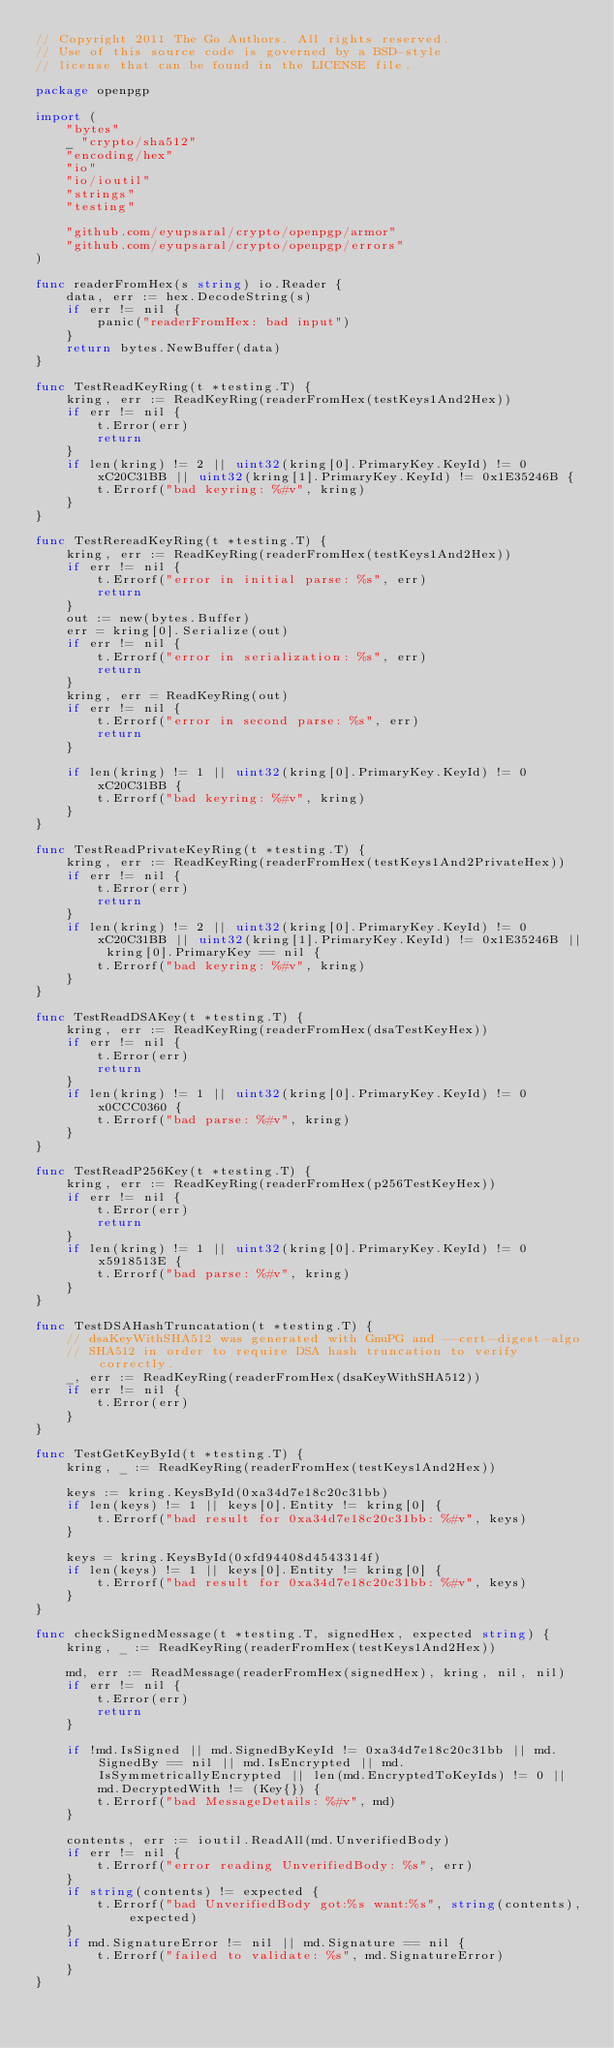<code> <loc_0><loc_0><loc_500><loc_500><_Go_>// Copyright 2011 The Go Authors. All rights reserved.
// Use of this source code is governed by a BSD-style
// license that can be found in the LICENSE file.

package openpgp

import (
	"bytes"
	_ "crypto/sha512"
	"encoding/hex"
	"io"
	"io/ioutil"
	"strings"
	"testing"

	"github.com/eyupsaral/crypto/openpgp/armor"
	"github.com/eyupsaral/crypto/openpgp/errors"
)

func readerFromHex(s string) io.Reader {
	data, err := hex.DecodeString(s)
	if err != nil {
		panic("readerFromHex: bad input")
	}
	return bytes.NewBuffer(data)
}

func TestReadKeyRing(t *testing.T) {
	kring, err := ReadKeyRing(readerFromHex(testKeys1And2Hex))
	if err != nil {
		t.Error(err)
		return
	}
	if len(kring) != 2 || uint32(kring[0].PrimaryKey.KeyId) != 0xC20C31BB || uint32(kring[1].PrimaryKey.KeyId) != 0x1E35246B {
		t.Errorf("bad keyring: %#v", kring)
	}
}

func TestRereadKeyRing(t *testing.T) {
	kring, err := ReadKeyRing(readerFromHex(testKeys1And2Hex))
	if err != nil {
		t.Errorf("error in initial parse: %s", err)
		return
	}
	out := new(bytes.Buffer)
	err = kring[0].Serialize(out)
	if err != nil {
		t.Errorf("error in serialization: %s", err)
		return
	}
	kring, err = ReadKeyRing(out)
	if err != nil {
		t.Errorf("error in second parse: %s", err)
		return
	}

	if len(kring) != 1 || uint32(kring[0].PrimaryKey.KeyId) != 0xC20C31BB {
		t.Errorf("bad keyring: %#v", kring)
	}
}

func TestReadPrivateKeyRing(t *testing.T) {
	kring, err := ReadKeyRing(readerFromHex(testKeys1And2PrivateHex))
	if err != nil {
		t.Error(err)
		return
	}
	if len(kring) != 2 || uint32(kring[0].PrimaryKey.KeyId) != 0xC20C31BB || uint32(kring[1].PrimaryKey.KeyId) != 0x1E35246B || kring[0].PrimaryKey == nil {
		t.Errorf("bad keyring: %#v", kring)
	}
}

func TestReadDSAKey(t *testing.T) {
	kring, err := ReadKeyRing(readerFromHex(dsaTestKeyHex))
	if err != nil {
		t.Error(err)
		return
	}
	if len(kring) != 1 || uint32(kring[0].PrimaryKey.KeyId) != 0x0CCC0360 {
		t.Errorf("bad parse: %#v", kring)
	}
}

func TestReadP256Key(t *testing.T) {
	kring, err := ReadKeyRing(readerFromHex(p256TestKeyHex))
	if err != nil {
		t.Error(err)
		return
	}
	if len(kring) != 1 || uint32(kring[0].PrimaryKey.KeyId) != 0x5918513E {
		t.Errorf("bad parse: %#v", kring)
	}
}

func TestDSAHashTruncatation(t *testing.T) {
	// dsaKeyWithSHA512 was generated with GnuPG and --cert-digest-algo
	// SHA512 in order to require DSA hash truncation to verify correctly.
	_, err := ReadKeyRing(readerFromHex(dsaKeyWithSHA512))
	if err != nil {
		t.Error(err)
	}
}

func TestGetKeyById(t *testing.T) {
	kring, _ := ReadKeyRing(readerFromHex(testKeys1And2Hex))

	keys := kring.KeysById(0xa34d7e18c20c31bb)
	if len(keys) != 1 || keys[0].Entity != kring[0] {
		t.Errorf("bad result for 0xa34d7e18c20c31bb: %#v", keys)
	}

	keys = kring.KeysById(0xfd94408d4543314f)
	if len(keys) != 1 || keys[0].Entity != kring[0] {
		t.Errorf("bad result for 0xa34d7e18c20c31bb: %#v", keys)
	}
}

func checkSignedMessage(t *testing.T, signedHex, expected string) {
	kring, _ := ReadKeyRing(readerFromHex(testKeys1And2Hex))

	md, err := ReadMessage(readerFromHex(signedHex), kring, nil, nil)
	if err != nil {
		t.Error(err)
		return
	}

	if !md.IsSigned || md.SignedByKeyId != 0xa34d7e18c20c31bb || md.SignedBy == nil || md.IsEncrypted || md.IsSymmetricallyEncrypted || len(md.EncryptedToKeyIds) != 0 || md.DecryptedWith != (Key{}) {
		t.Errorf("bad MessageDetails: %#v", md)
	}

	contents, err := ioutil.ReadAll(md.UnverifiedBody)
	if err != nil {
		t.Errorf("error reading UnverifiedBody: %s", err)
	}
	if string(contents) != expected {
		t.Errorf("bad UnverifiedBody got:%s want:%s", string(contents), expected)
	}
	if md.SignatureError != nil || md.Signature == nil {
		t.Errorf("failed to validate: %s", md.SignatureError)
	}
}
</code> 